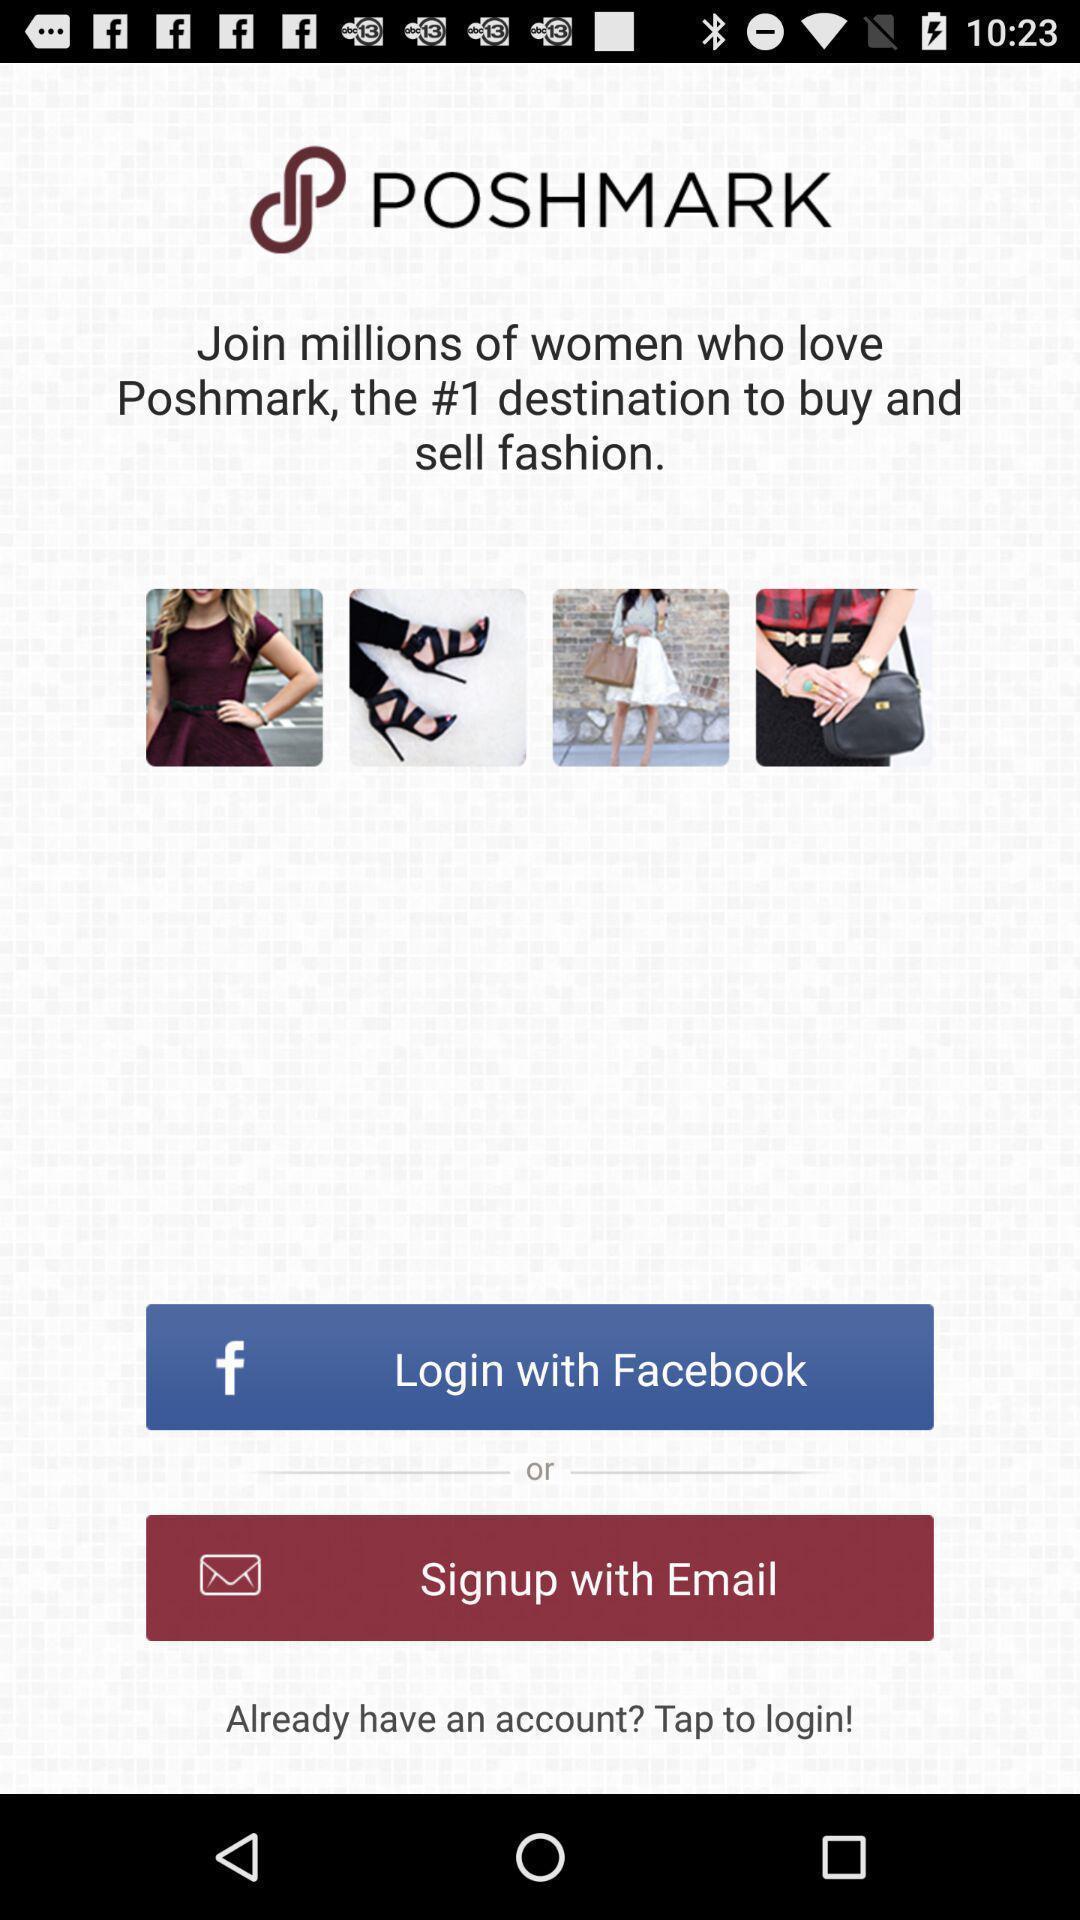Describe the content in this image. Welcome page of an e-commerce app. 